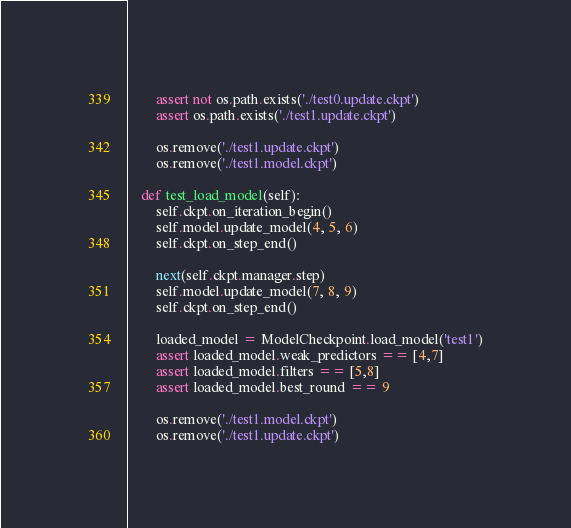Convert code to text. <code><loc_0><loc_0><loc_500><loc_500><_Python_>
        assert not os.path.exists('./test0.update.ckpt')
        assert os.path.exists('./test1.update.ckpt')

        os.remove('./test1.update.ckpt')
        os.remove('./test1.model.ckpt')

    def test_load_model(self):
        self.ckpt.on_iteration_begin()
        self.model.update_model(4, 5, 6)
        self.ckpt.on_step_end()

        next(self.ckpt.manager.step)
        self.model.update_model(7, 8, 9)
        self.ckpt.on_step_end()

        loaded_model = ModelCheckpoint.load_model('test1')
        assert loaded_model.weak_predictors == [4,7]
        assert loaded_model.filters == [5,8]
        assert loaded_model.best_round == 9

        os.remove('./test1.model.ckpt')
        os.remove('./test1.update.ckpt')
</code> 